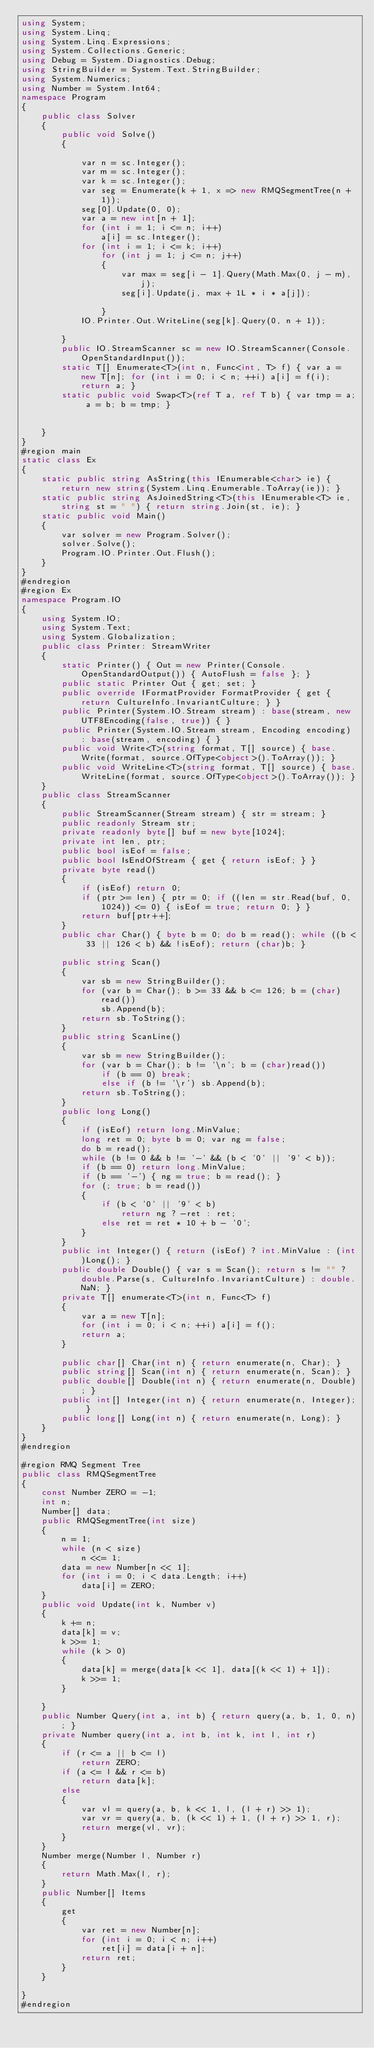Convert code to text. <code><loc_0><loc_0><loc_500><loc_500><_C#_>using System;
using System.Linq;
using System.Linq.Expressions;
using System.Collections.Generic;
using Debug = System.Diagnostics.Debug;
using StringBuilder = System.Text.StringBuilder;
using System.Numerics;
using Number = System.Int64;
namespace Program
{
    public class Solver
    {
        public void Solve()
        {

            var n = sc.Integer();
            var m = sc.Integer();
            var k = sc.Integer();
            var seg = Enumerate(k + 1, x => new RMQSegmentTree(n + 1));
            seg[0].Update(0, 0);
            var a = new int[n + 1];
            for (int i = 1; i <= n; i++)
                a[i] = sc.Integer();
            for (int i = 1; i <= k; i++)
                for (int j = 1; j <= n; j++)
                {
                    var max = seg[i - 1].Query(Math.Max(0, j - m), j);
                    seg[i].Update(j, max + 1L * i * a[j]);

                }
            IO.Printer.Out.WriteLine(seg[k].Query(0, n + 1));

        }
        public IO.StreamScanner sc = new IO.StreamScanner(Console.OpenStandardInput());
        static T[] Enumerate<T>(int n, Func<int, T> f) { var a = new T[n]; for (int i = 0; i < n; ++i) a[i] = f(i); return a; }
        static public void Swap<T>(ref T a, ref T b) { var tmp = a; a = b; b = tmp; }


    }
}
#region main
static class Ex
{
    static public string AsString(this IEnumerable<char> ie) { return new string(System.Linq.Enumerable.ToArray(ie)); }
    static public string AsJoinedString<T>(this IEnumerable<T> ie, string st = " ") { return string.Join(st, ie); }
    static public void Main()
    {
        var solver = new Program.Solver();
        solver.Solve();
        Program.IO.Printer.Out.Flush();
    }
}
#endregion
#region Ex
namespace Program.IO
{
    using System.IO;
    using System.Text;
    using System.Globalization;
    public class Printer: StreamWriter
    {
        static Printer() { Out = new Printer(Console.OpenStandardOutput()) { AutoFlush = false }; }
        public static Printer Out { get; set; }
        public override IFormatProvider FormatProvider { get { return CultureInfo.InvariantCulture; } }
        public Printer(System.IO.Stream stream) : base(stream, new UTF8Encoding(false, true)) { }
        public Printer(System.IO.Stream stream, Encoding encoding) : base(stream, encoding) { }
        public void Write<T>(string format, T[] source) { base.Write(format, source.OfType<object>().ToArray()); }
        public void WriteLine<T>(string format, T[] source) { base.WriteLine(format, source.OfType<object>().ToArray()); }
    }
    public class StreamScanner
    {
        public StreamScanner(Stream stream) { str = stream; }
        public readonly Stream str;
        private readonly byte[] buf = new byte[1024];
        private int len, ptr;
        public bool isEof = false;
        public bool IsEndOfStream { get { return isEof; } }
        private byte read()
        {
            if (isEof) return 0;
            if (ptr >= len) { ptr = 0; if ((len = str.Read(buf, 0, 1024)) <= 0) { isEof = true; return 0; } }
            return buf[ptr++];
        }
        public char Char() { byte b = 0; do b = read(); while ((b < 33 || 126 < b) && !isEof); return (char)b; }

        public string Scan()
        {
            var sb = new StringBuilder();
            for (var b = Char(); b >= 33 && b <= 126; b = (char)read())
                sb.Append(b);
            return sb.ToString();
        }
        public string ScanLine()
        {
            var sb = new StringBuilder();
            for (var b = Char(); b != '\n'; b = (char)read())
                if (b == 0) break;
                else if (b != '\r') sb.Append(b);
            return sb.ToString();
        }
        public long Long()
        {
            if (isEof) return long.MinValue;
            long ret = 0; byte b = 0; var ng = false;
            do b = read();
            while (b != 0 && b != '-' && (b < '0' || '9' < b));
            if (b == 0) return long.MinValue;
            if (b == '-') { ng = true; b = read(); }
            for (; true; b = read())
            {
                if (b < '0' || '9' < b)
                    return ng ? -ret : ret;
                else ret = ret * 10 + b - '0';
            }
        }
        public int Integer() { return (isEof) ? int.MinValue : (int)Long(); }
        public double Double() { var s = Scan(); return s != "" ? double.Parse(s, CultureInfo.InvariantCulture) : double.NaN; }
        private T[] enumerate<T>(int n, Func<T> f)
        {
            var a = new T[n];
            for (int i = 0; i < n; ++i) a[i] = f();
            return a;
        }

        public char[] Char(int n) { return enumerate(n, Char); }
        public string[] Scan(int n) { return enumerate(n, Scan); }
        public double[] Double(int n) { return enumerate(n, Double); }
        public int[] Integer(int n) { return enumerate(n, Integer); }
        public long[] Long(int n) { return enumerate(n, Long); }
    }
}
#endregion

#region RMQ Segment Tree
public class RMQSegmentTree
{
    const Number ZERO = -1;
    int n;
    Number[] data;
    public RMQSegmentTree(int size)
    {
        n = 1;
        while (n < size)
            n <<= 1;
        data = new Number[n << 1];
        for (int i = 0; i < data.Length; i++)
            data[i] = ZERO;
    }
    public void Update(int k, Number v)
    {
        k += n;
        data[k] = v;
        k >>= 1;
        while (k > 0)
        {
            data[k] = merge(data[k << 1], data[(k << 1) + 1]);
            k >>= 1;
        }

    }
    public Number Query(int a, int b) { return query(a, b, 1, 0, n); }
    private Number query(int a, int b, int k, int l, int r)
    {
        if (r <= a || b <= l)
            return ZERO;
        if (a <= l && r <= b)
            return data[k];
        else
        {
            var vl = query(a, b, k << 1, l, (l + r) >> 1);
            var vr = query(a, b, (k << 1) + 1, (l + r) >> 1, r);
            return merge(vl, vr);
        }
    }
    Number merge(Number l, Number r)
    {
        return Math.Max(l, r);
    }
    public Number[] Items
    {
        get
        {
            var ret = new Number[n];
            for (int i = 0; i < n; i++)
                ret[i] = data[i + n];
            return ret;
        }
    }

}
#endregion</code> 